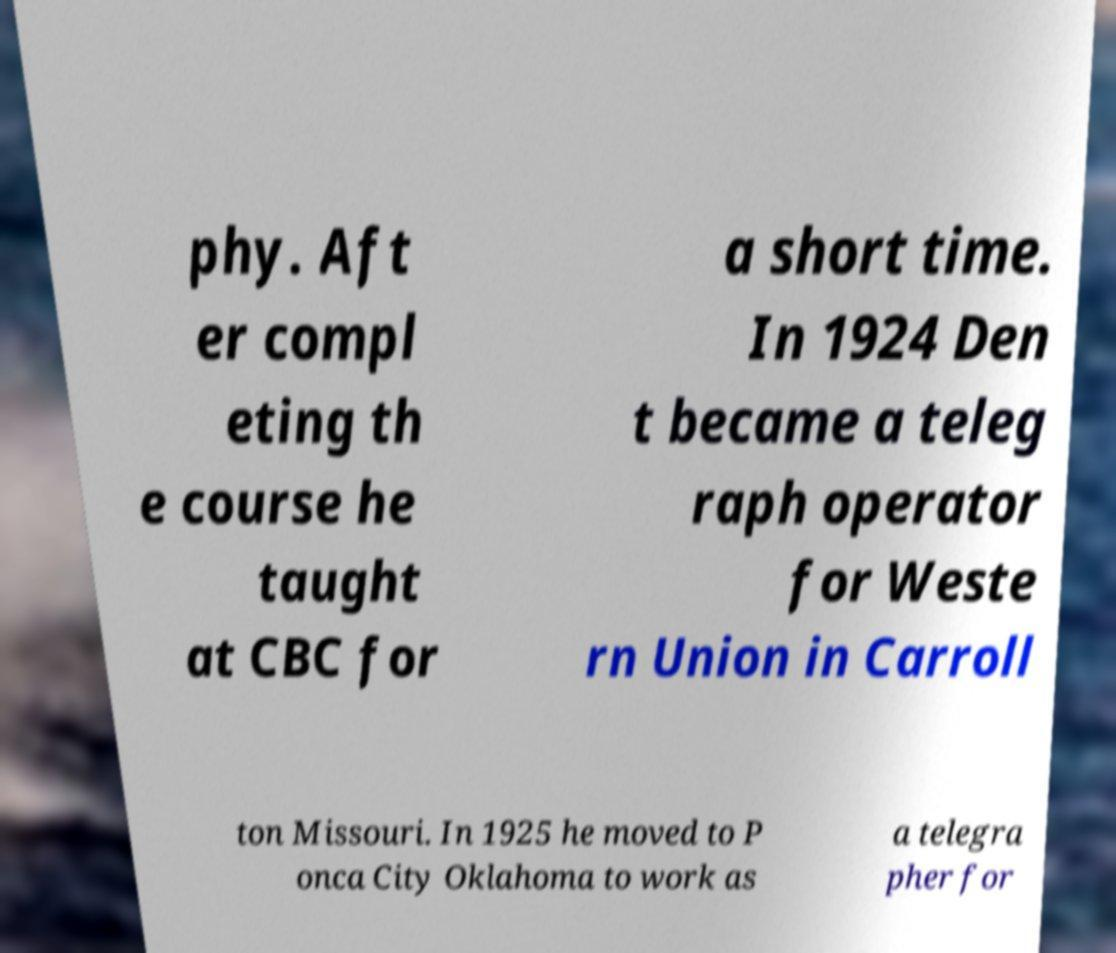Could you extract and type out the text from this image? phy. Aft er compl eting th e course he taught at CBC for a short time. In 1924 Den t became a teleg raph operator for Weste rn Union in Carroll ton Missouri. In 1925 he moved to P onca City Oklahoma to work as a telegra pher for 